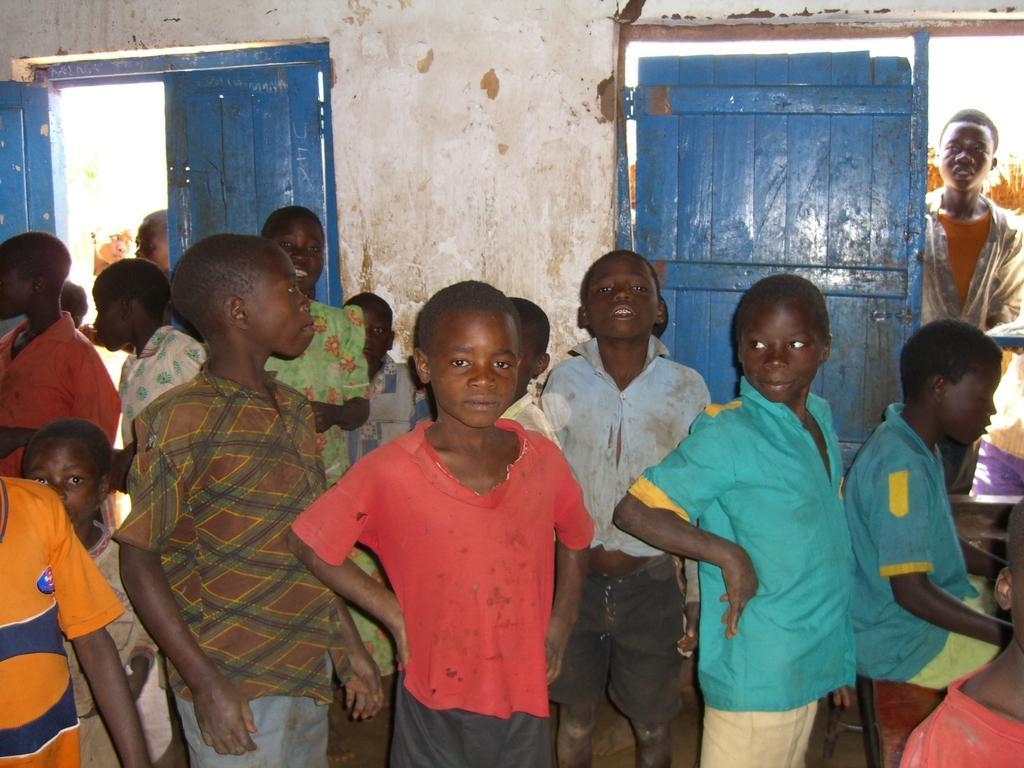In one or two sentences, can you explain what this image depicts? There are group of children standing. These are the wooden doors. I can see a person standing near the door. This is the wall. This looks like a bench. I can see a boy sitting. 